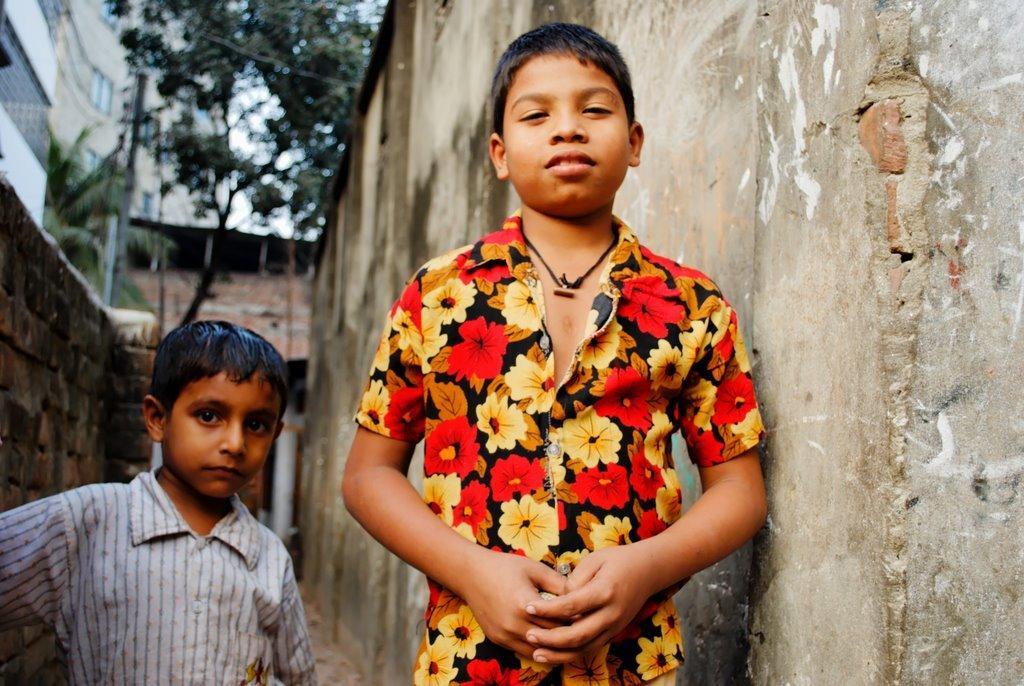Describe this image in one or two sentences. Her two children are standing, here there is a building, here there is a tree. 